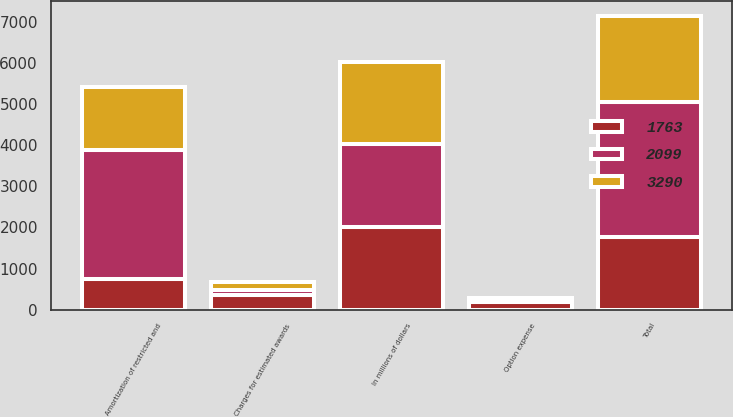<chart> <loc_0><loc_0><loc_500><loc_500><stacked_bar_chart><ecel><fcel>In millions of dollars<fcel>Charges for estimated awards<fcel>Option expense<fcel>Amortization of restricted and<fcel>Total<nl><fcel>1763<fcel>2010<fcel>366<fcel>197<fcel>747<fcel>1763<nl><fcel>3290<fcel>2009<fcel>207<fcel>55<fcel>1543<fcel>2099<nl><fcel>2099<fcel>2008<fcel>110<fcel>29<fcel>3133<fcel>3290<nl></chart> 